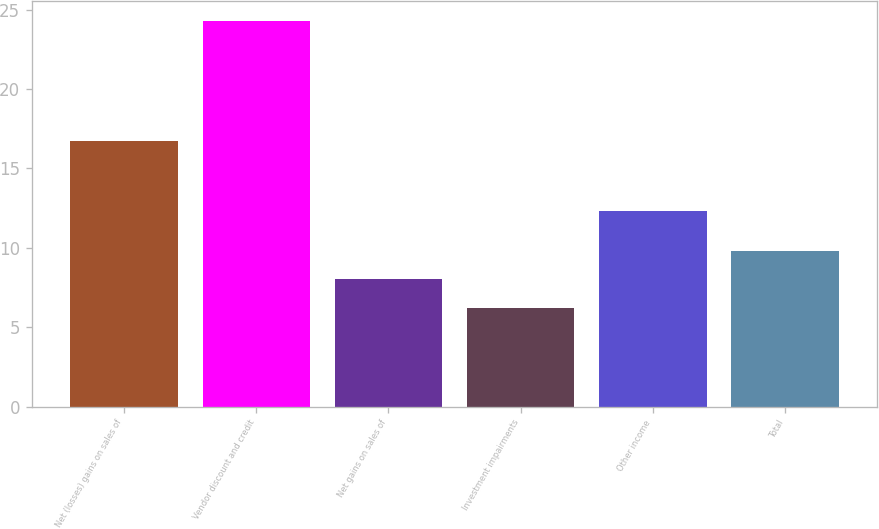<chart> <loc_0><loc_0><loc_500><loc_500><bar_chart><fcel>Net (losses) gains on sales of<fcel>Vendor discount and credit<fcel>Net gains on sales of<fcel>Investment impairments<fcel>Other income<fcel>Total<nl><fcel>16.7<fcel>24.3<fcel>8.01<fcel>6.2<fcel>12.3<fcel>9.82<nl></chart> 